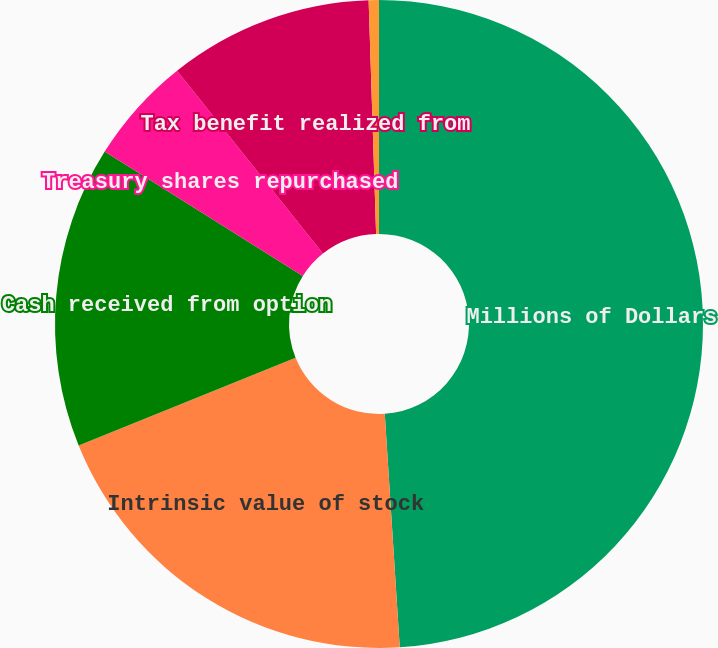<chart> <loc_0><loc_0><loc_500><loc_500><pie_chart><fcel>Millions of Dollars<fcel>Intrinsic value of stock<fcel>Cash received from option<fcel>Treasury shares repurchased<fcel>Tax benefit realized from<fcel>Aggregate grant-date fair<nl><fcel>48.98%<fcel>19.9%<fcel>15.05%<fcel>5.36%<fcel>10.2%<fcel>0.51%<nl></chart> 